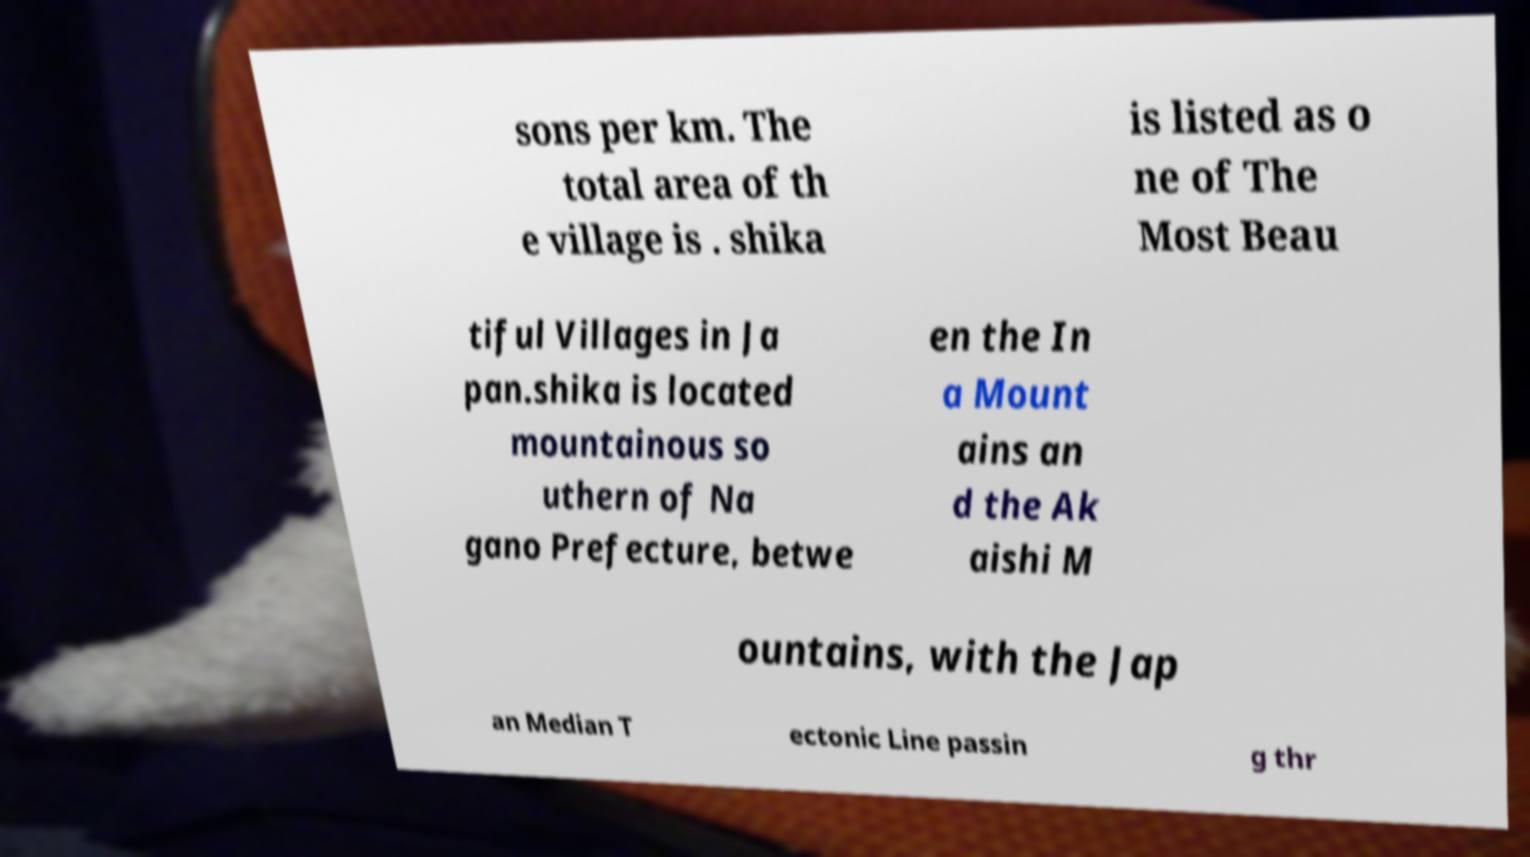Could you assist in decoding the text presented in this image and type it out clearly? sons per km. The total area of th e village is . shika is listed as o ne of The Most Beau tiful Villages in Ja pan.shika is located mountainous so uthern of Na gano Prefecture, betwe en the In a Mount ains an d the Ak aishi M ountains, with the Jap an Median T ectonic Line passin g thr 